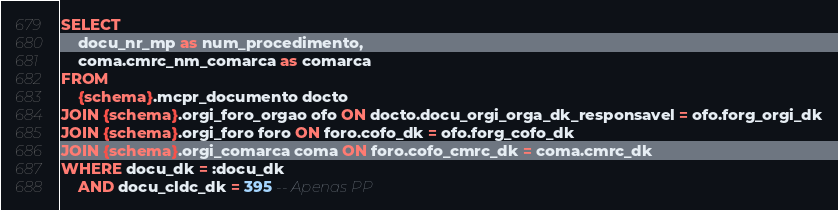<code> <loc_0><loc_0><loc_500><loc_500><_SQL_>SELECT
    docu_nr_mp as num_procedimento,
    coma.cmrc_nm_comarca as comarca
FROM
    {schema}.mcpr_documento docto
JOIN {schema}.orgi_foro_orgao ofo ON docto.docu_orgi_orga_dk_responsavel = ofo.forg_orgi_dk
JOIN {schema}.orgi_foro foro ON foro.cofo_dk = ofo.forg_cofo_dk
JOIN {schema}.orgi_comarca coma ON foro.cofo_cmrc_dk = coma.cmrc_dk
WHERE docu_dk = :docu_dk
    AND docu_cldc_dk = 395 -- Apenas PP
</code> 